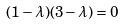<formula> <loc_0><loc_0><loc_500><loc_500>( 1 - \lambda ) ( 3 - \lambda ) = 0</formula> 